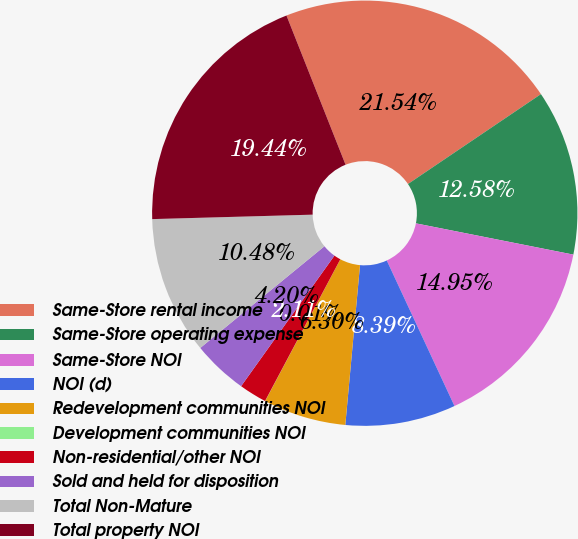<chart> <loc_0><loc_0><loc_500><loc_500><pie_chart><fcel>Same-Store rental income<fcel>Same-Store operating expense<fcel>Same-Store NOI<fcel>NOI (d)<fcel>Redevelopment communities NOI<fcel>Development communities NOI<fcel>Non-residential/other NOI<fcel>Sold and held for disposition<fcel>Total Non-Mature<fcel>Total property NOI<nl><fcel>21.54%<fcel>12.58%<fcel>14.95%<fcel>8.39%<fcel>6.3%<fcel>0.01%<fcel>2.11%<fcel>4.2%<fcel>10.48%<fcel>19.44%<nl></chart> 